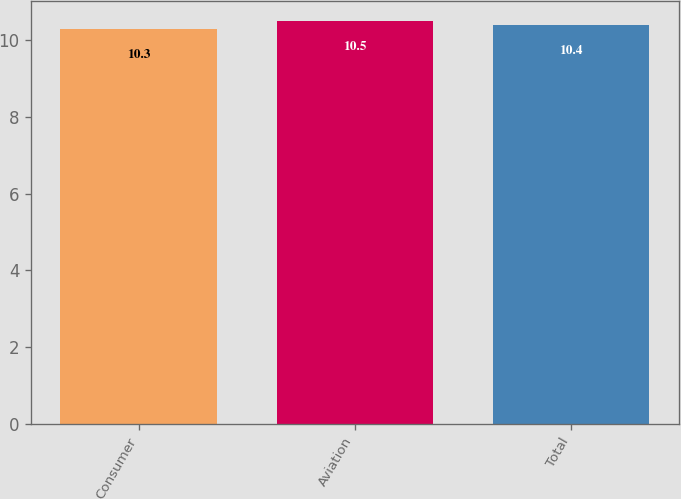Convert chart. <chart><loc_0><loc_0><loc_500><loc_500><bar_chart><fcel>Consumer<fcel>Aviation<fcel>Total<nl><fcel>10.3<fcel>10.5<fcel>10.4<nl></chart> 